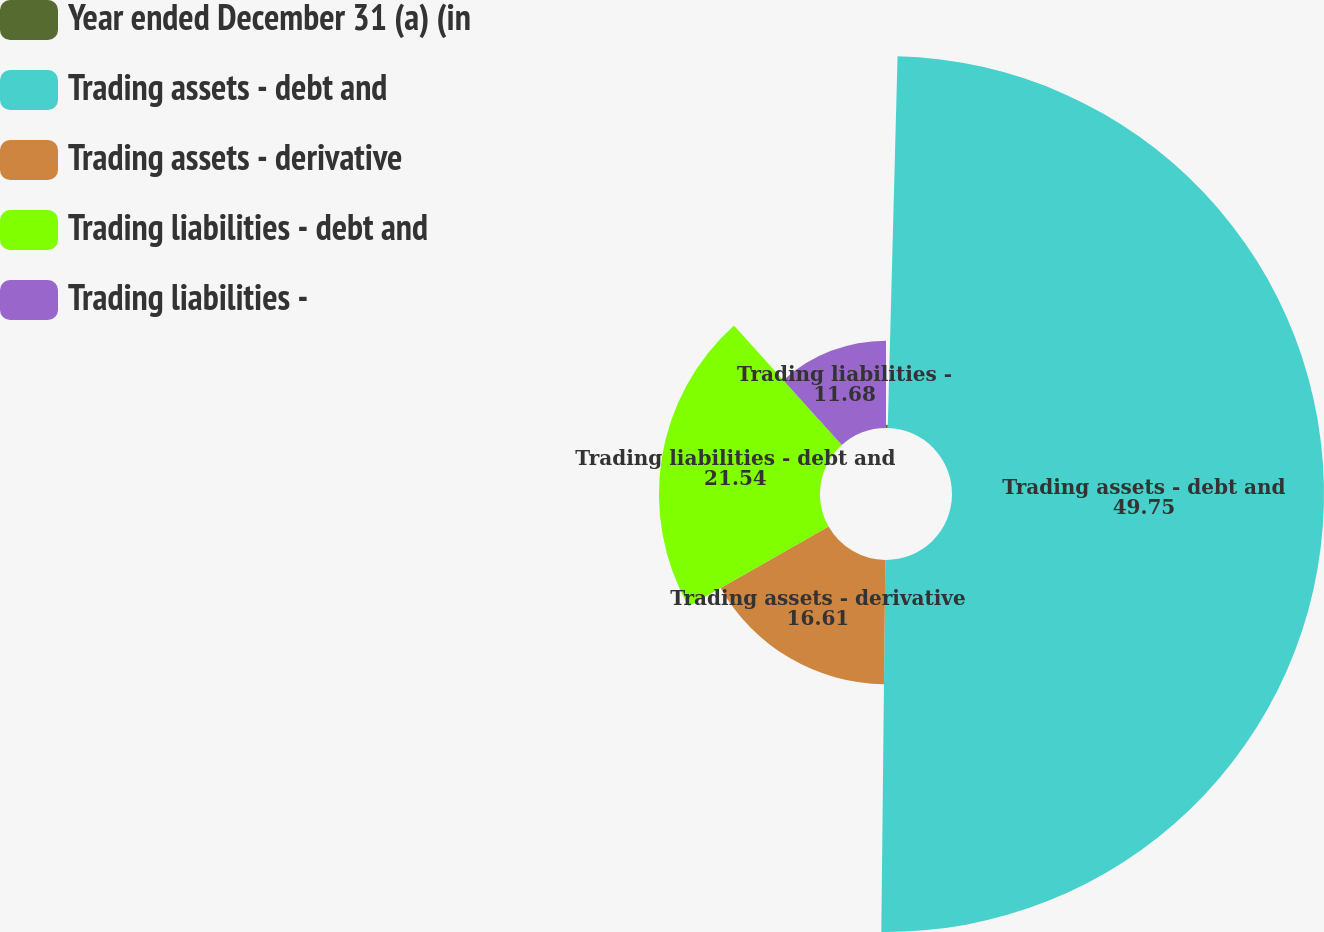Convert chart. <chart><loc_0><loc_0><loc_500><loc_500><pie_chart><fcel>Year ended December 31 (a) (in<fcel>Trading assets - debt and<fcel>Trading assets - derivative<fcel>Trading liabilities - debt and<fcel>Trading liabilities -<nl><fcel>0.42%<fcel>49.75%<fcel>16.61%<fcel>21.54%<fcel>11.68%<nl></chart> 